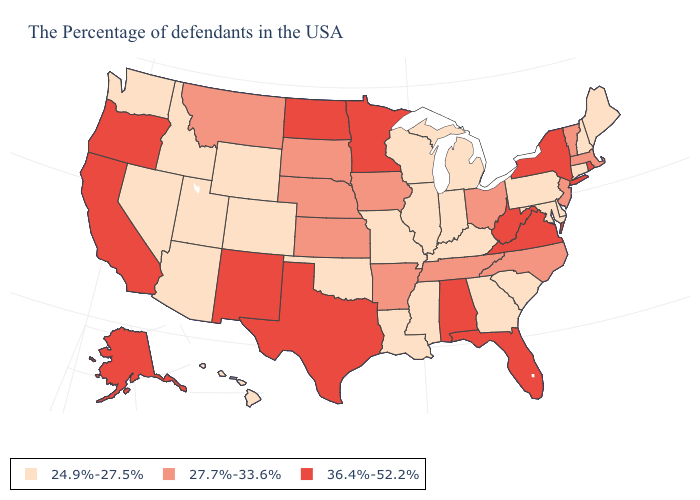Name the states that have a value in the range 24.9%-27.5%?
Quick response, please. Maine, New Hampshire, Connecticut, Delaware, Maryland, Pennsylvania, South Carolina, Georgia, Michigan, Kentucky, Indiana, Wisconsin, Illinois, Mississippi, Louisiana, Missouri, Oklahoma, Wyoming, Colorado, Utah, Arizona, Idaho, Nevada, Washington, Hawaii. What is the value of Idaho?
Concise answer only. 24.9%-27.5%. Does Montana have the lowest value in the West?
Answer briefly. No. Name the states that have a value in the range 27.7%-33.6%?
Quick response, please. Massachusetts, Vermont, New Jersey, North Carolina, Ohio, Tennessee, Arkansas, Iowa, Kansas, Nebraska, South Dakota, Montana. What is the value of Utah?
Quick response, please. 24.9%-27.5%. Is the legend a continuous bar?
Short answer required. No. What is the highest value in states that border Louisiana?
Short answer required. 36.4%-52.2%. What is the value of Kentucky?
Answer briefly. 24.9%-27.5%. Which states have the lowest value in the West?
Short answer required. Wyoming, Colorado, Utah, Arizona, Idaho, Nevada, Washington, Hawaii. Name the states that have a value in the range 24.9%-27.5%?
Answer briefly. Maine, New Hampshire, Connecticut, Delaware, Maryland, Pennsylvania, South Carolina, Georgia, Michigan, Kentucky, Indiana, Wisconsin, Illinois, Mississippi, Louisiana, Missouri, Oklahoma, Wyoming, Colorado, Utah, Arizona, Idaho, Nevada, Washington, Hawaii. Name the states that have a value in the range 27.7%-33.6%?
Short answer required. Massachusetts, Vermont, New Jersey, North Carolina, Ohio, Tennessee, Arkansas, Iowa, Kansas, Nebraska, South Dakota, Montana. Does Vermont have the lowest value in the Northeast?
Keep it brief. No. Name the states that have a value in the range 36.4%-52.2%?
Keep it brief. Rhode Island, New York, Virginia, West Virginia, Florida, Alabama, Minnesota, Texas, North Dakota, New Mexico, California, Oregon, Alaska. Does Rhode Island have the highest value in the Northeast?
Write a very short answer. Yes. Name the states that have a value in the range 24.9%-27.5%?
Keep it brief. Maine, New Hampshire, Connecticut, Delaware, Maryland, Pennsylvania, South Carolina, Georgia, Michigan, Kentucky, Indiana, Wisconsin, Illinois, Mississippi, Louisiana, Missouri, Oklahoma, Wyoming, Colorado, Utah, Arizona, Idaho, Nevada, Washington, Hawaii. 